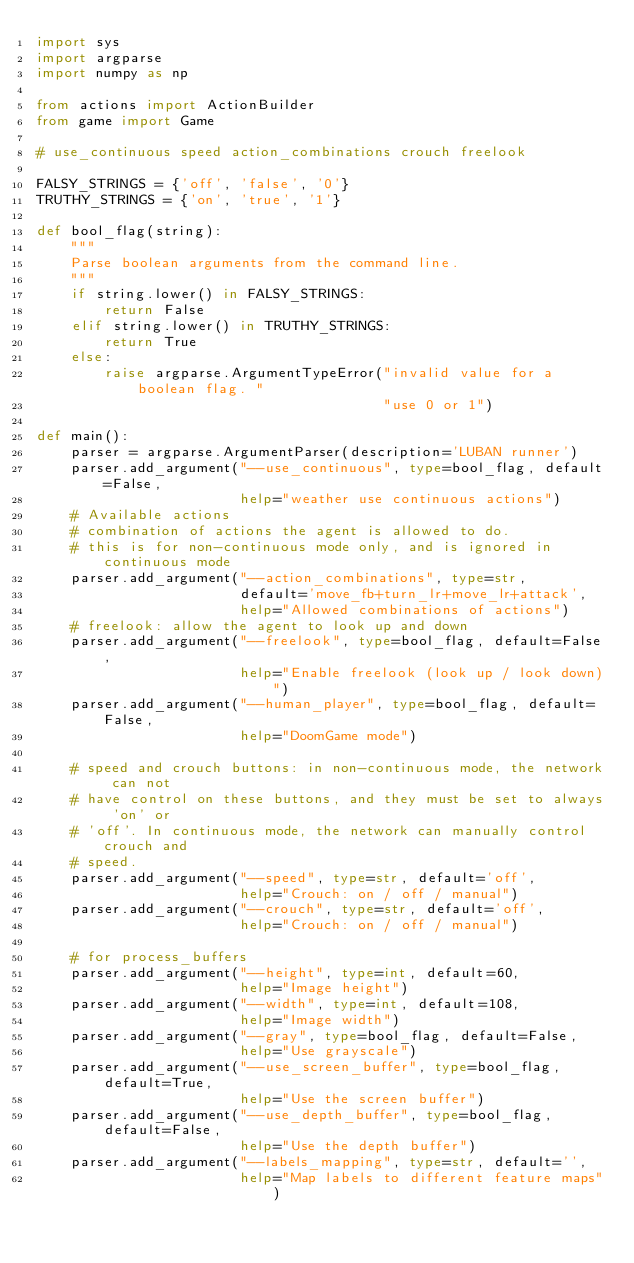Convert code to text. <code><loc_0><loc_0><loc_500><loc_500><_Python_>import sys
import argparse
import numpy as np

from actions import ActionBuilder
from game import Game

# use_continuous speed action_combinations crouch freelook

FALSY_STRINGS = {'off', 'false', '0'}
TRUTHY_STRINGS = {'on', 'true', '1'}

def bool_flag(string):
    """
    Parse boolean arguments from the command line.
    """
    if string.lower() in FALSY_STRINGS:
        return False
    elif string.lower() in TRUTHY_STRINGS:
        return True
    else:
        raise argparse.ArgumentTypeError("invalid value for a boolean flag. "
                                         "use 0 or 1")

def main():
    parser = argparse.ArgumentParser(description='LUBAN runner')
    parser.add_argument("--use_continuous", type=bool_flag, default=False,
                        help="weather use continuous actions")
    # Available actions
    # combination of actions the agent is allowed to do.
    # this is for non-continuous mode only, and is ignored in continuous mode
    parser.add_argument("--action_combinations", type=str,
                        default='move_fb+turn_lr+move_lr+attack',
                        help="Allowed combinations of actions")
    # freelook: allow the agent to look up and down
    parser.add_argument("--freelook", type=bool_flag, default=False,
                        help="Enable freelook (look up / look down)")
    parser.add_argument("--human_player", type=bool_flag, default=False,
                        help="DoomGame mode")

    # speed and crouch buttons: in non-continuous mode, the network can not
    # have control on these buttons, and they must be set to always 'on' or
    # 'off'. In continuous mode, the network can manually control crouch and
    # speed.
    parser.add_argument("--speed", type=str, default='off',
                        help="Crouch: on / off / manual")
    parser.add_argument("--crouch", type=str, default='off',
                        help="Crouch: on / off / manual")

    # for process_buffers
    parser.add_argument("--height", type=int, default=60,
                        help="Image height")
    parser.add_argument("--width", type=int, default=108,
                        help="Image width")
    parser.add_argument("--gray", type=bool_flag, default=False,
                        help="Use grayscale")
    parser.add_argument("--use_screen_buffer", type=bool_flag, default=True,
                        help="Use the screen buffer")
    parser.add_argument("--use_depth_buffer", type=bool_flag, default=False,
                        help="Use the depth buffer")
    parser.add_argument("--labels_mapping", type=str, default='',
                        help="Map labels to different feature maps")</code> 